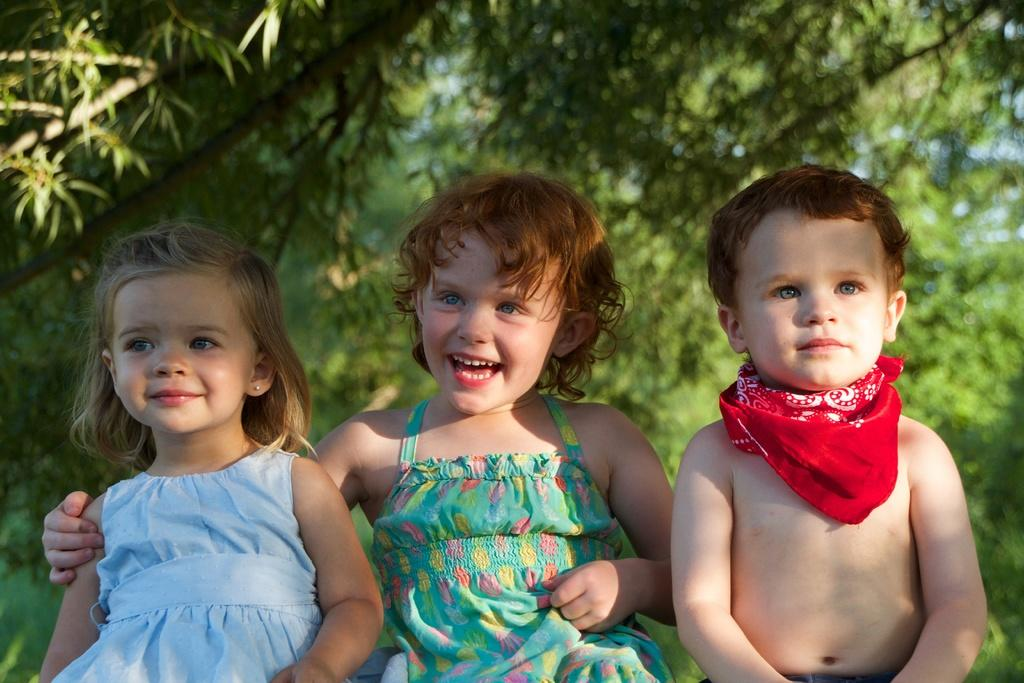How many children are present in the image? There are three children in the image. What is the facial expression of the children? The children are smiling. What can be seen in the background of the image? There are trees in the background of the image. What type of vegetable is being harvested by the children in the image? There is no vegetable being harvested in the image; the children are simply smiling. What surgical procedure is being performed on the children in the image? There is no operation or surgical procedure being performed on the children in the image; they are simply smiling. 